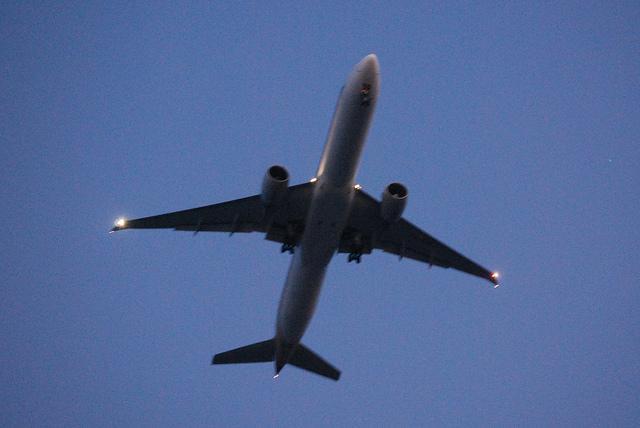How many different colors is this airplane?
Give a very brief answer. 1. How many engines does this craft have?
Give a very brief answer. 2. 